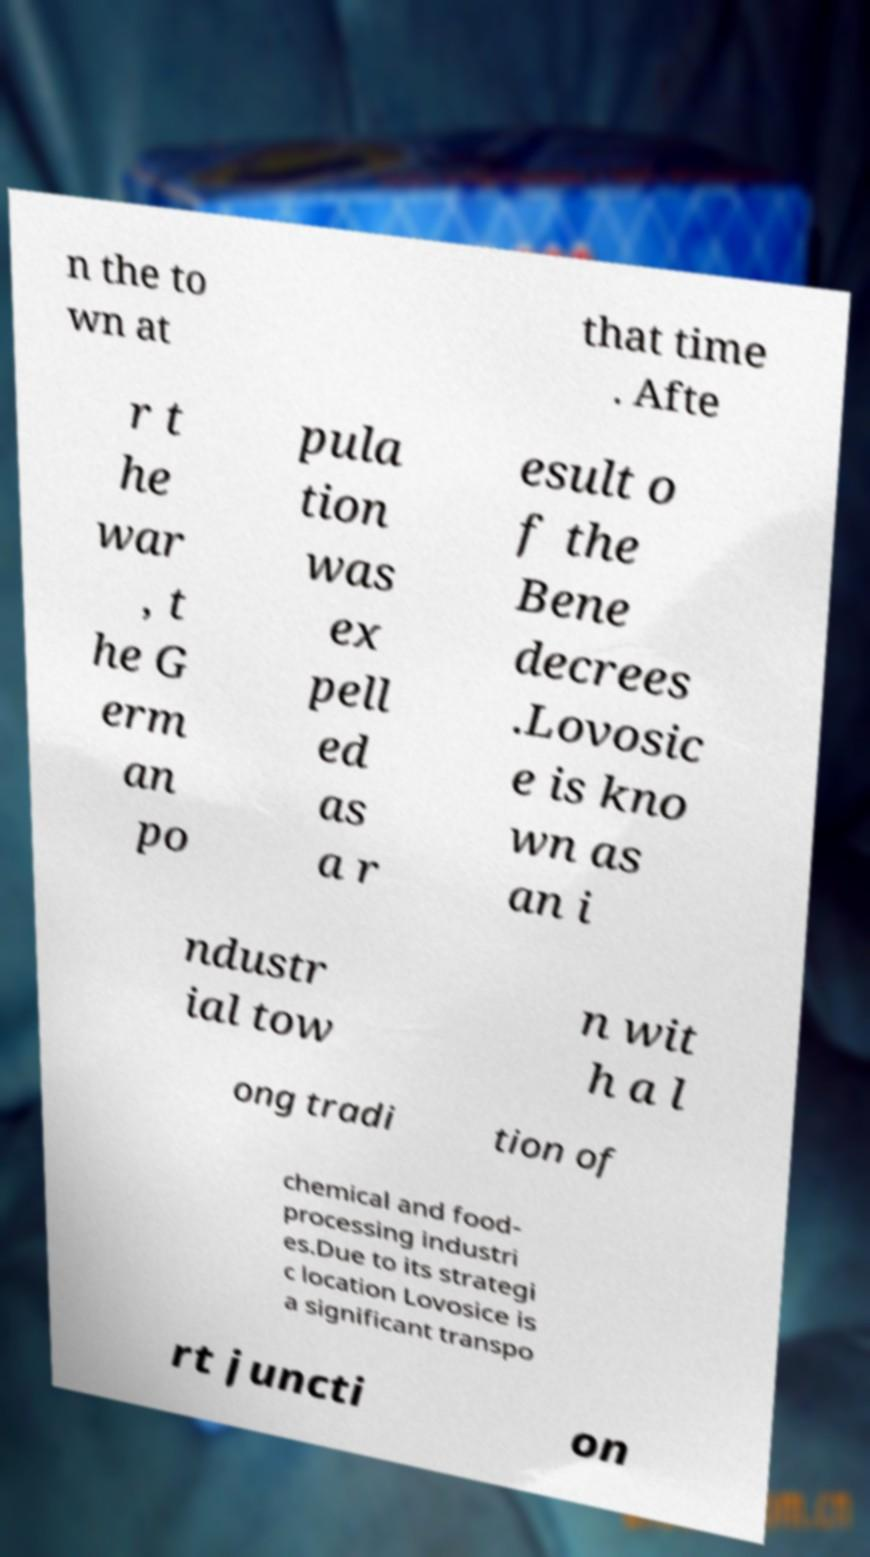What messages or text are displayed in this image? I need them in a readable, typed format. n the to wn at that time . Afte r t he war , t he G erm an po pula tion was ex pell ed as a r esult o f the Bene decrees .Lovosic e is kno wn as an i ndustr ial tow n wit h a l ong tradi tion of chemical and food- processing industri es.Due to its strategi c location Lovosice is a significant transpo rt juncti on 